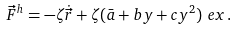Convert formula to latex. <formula><loc_0><loc_0><loc_500><loc_500>\vec { F } ^ { h } & = - \zeta \dot { \vec { r } } + \zeta ( \bar { a } + b y + c y ^ { 2 } ) \ e x \, .</formula> 